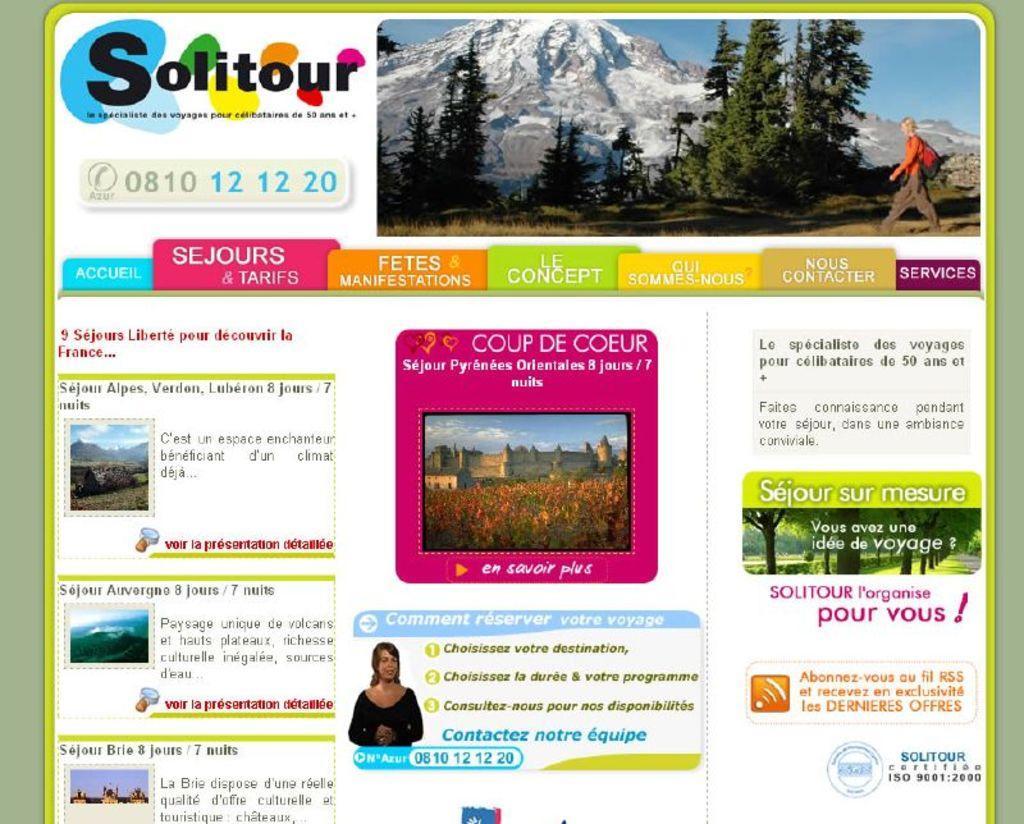Describe this image in one or two sentences. It is a digital poster, in this there are mountains, trees. 